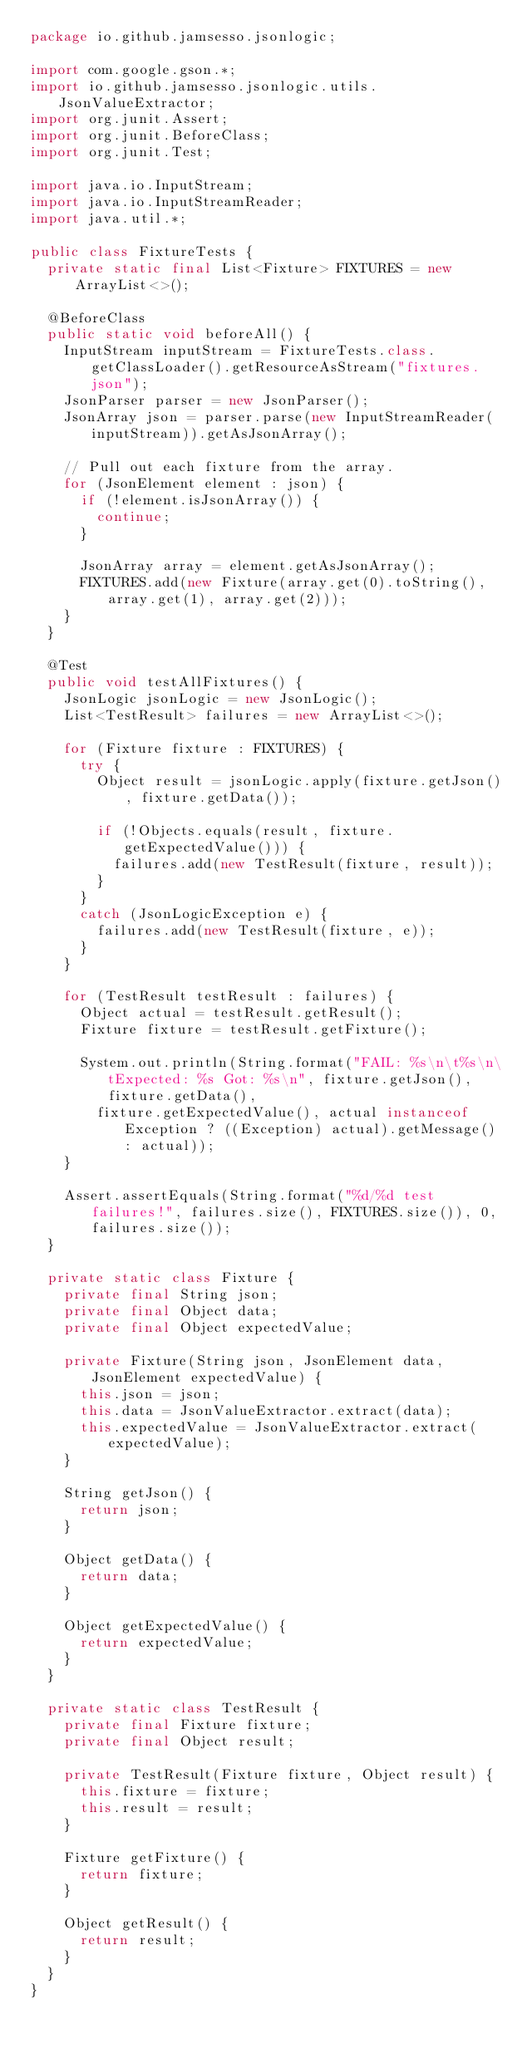Convert code to text. <code><loc_0><loc_0><loc_500><loc_500><_Java_>package io.github.jamsesso.jsonlogic;

import com.google.gson.*;
import io.github.jamsesso.jsonlogic.utils.JsonValueExtractor;
import org.junit.Assert;
import org.junit.BeforeClass;
import org.junit.Test;

import java.io.InputStream;
import java.io.InputStreamReader;
import java.util.*;

public class FixtureTests {
  private static final List<Fixture> FIXTURES = new ArrayList<>();

  @BeforeClass
  public static void beforeAll() {
    InputStream inputStream = FixtureTests.class.getClassLoader().getResourceAsStream("fixtures.json");
    JsonParser parser = new JsonParser();
    JsonArray json = parser.parse(new InputStreamReader(inputStream)).getAsJsonArray();

    // Pull out each fixture from the array.
    for (JsonElement element : json) {
      if (!element.isJsonArray()) {
        continue;
      }

      JsonArray array = element.getAsJsonArray();
      FIXTURES.add(new Fixture(array.get(0).toString(), array.get(1), array.get(2)));
    }
  }

  @Test
  public void testAllFixtures() {
    JsonLogic jsonLogic = new JsonLogic();
    List<TestResult> failures = new ArrayList<>();

    for (Fixture fixture : FIXTURES) {
      try {
        Object result = jsonLogic.apply(fixture.getJson(), fixture.getData());

        if (!Objects.equals(result, fixture.getExpectedValue())) {
          failures.add(new TestResult(fixture, result));
        }
      }
      catch (JsonLogicException e) {
        failures.add(new TestResult(fixture, e));
      }
    }

    for (TestResult testResult : failures) {
      Object actual = testResult.getResult();
      Fixture fixture = testResult.getFixture();

      System.out.println(String.format("FAIL: %s\n\t%s\n\tExpected: %s Got: %s\n", fixture.getJson(), fixture.getData(),
        fixture.getExpectedValue(), actual instanceof Exception ? ((Exception) actual).getMessage() : actual));
    }

    Assert.assertEquals(String.format("%d/%d test failures!", failures.size(), FIXTURES.size()), 0, failures.size());
  }

  private static class Fixture {
    private final String json;
    private final Object data;
    private final Object expectedValue;

    private Fixture(String json, JsonElement data, JsonElement expectedValue) {
      this.json = json;
      this.data = JsonValueExtractor.extract(data);
      this.expectedValue = JsonValueExtractor.extract(expectedValue);
    }

    String getJson() {
      return json;
    }

    Object getData() {
      return data;
    }

    Object getExpectedValue() {
      return expectedValue;
    }
  }

  private static class TestResult {
    private final Fixture fixture;
    private final Object result;

    private TestResult(Fixture fixture, Object result) {
      this.fixture = fixture;
      this.result = result;
    }

    Fixture getFixture() {
      return fixture;
    }

    Object getResult() {
      return result;
    }
  }
}
</code> 